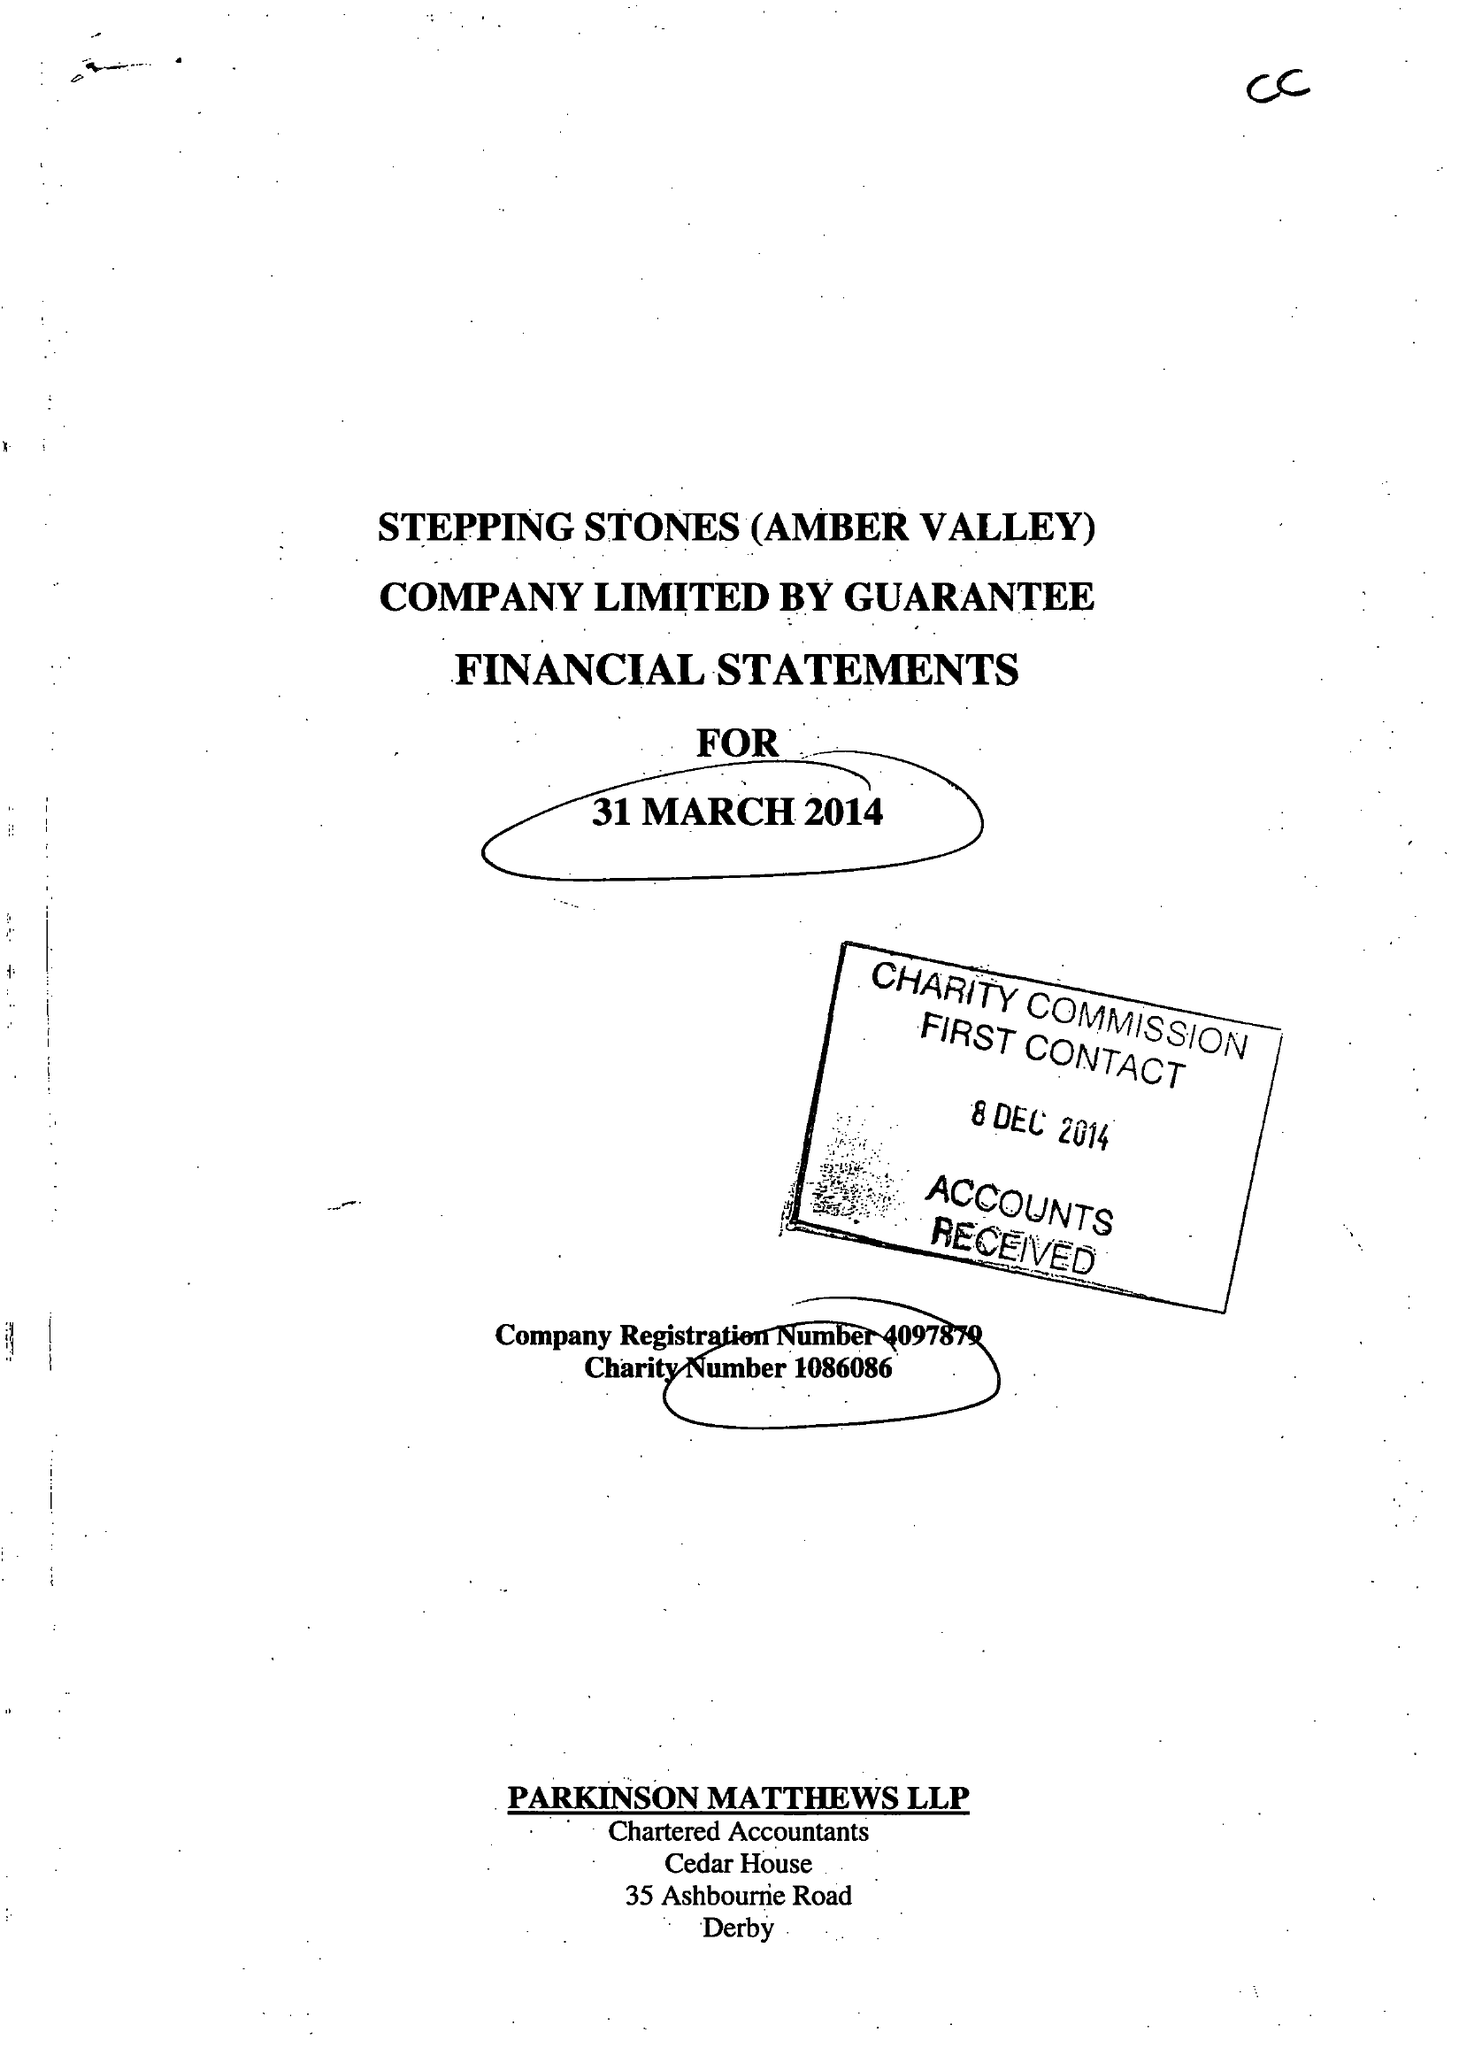What is the value for the address__postcode?
Answer the question using a single word or phrase. None 